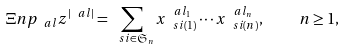Convert formula to latex. <formula><loc_0><loc_0><loc_500><loc_500>\Xi n p _ { \ a l } z ^ { | \ a l | } = \sum _ { \ s i \in \mathfrak { S } _ { n } } x _ { \ s i ( 1 ) } ^ { \ a l _ { 1 } } \cdots x _ { \ s i ( n ) } ^ { \ a l _ { n } } , \quad n \geq 1 ,</formula> 